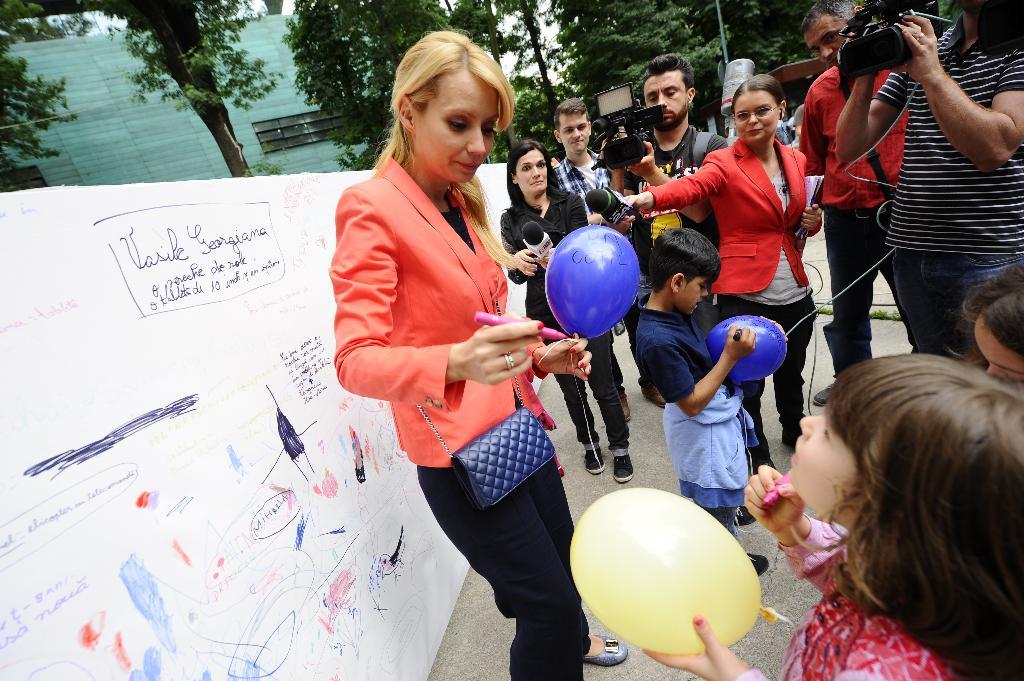How would you summarize this image in a sentence or two? In this image there are a few people holding mix and few are holding cameras, there are few children's holding balloons and sketch in their hands, in front of them there is a woman wearing handbag and holding a sketch in one hand and a balloon in the other hand, behind her there is a board with some text on it and in the background there is a building and trees. 